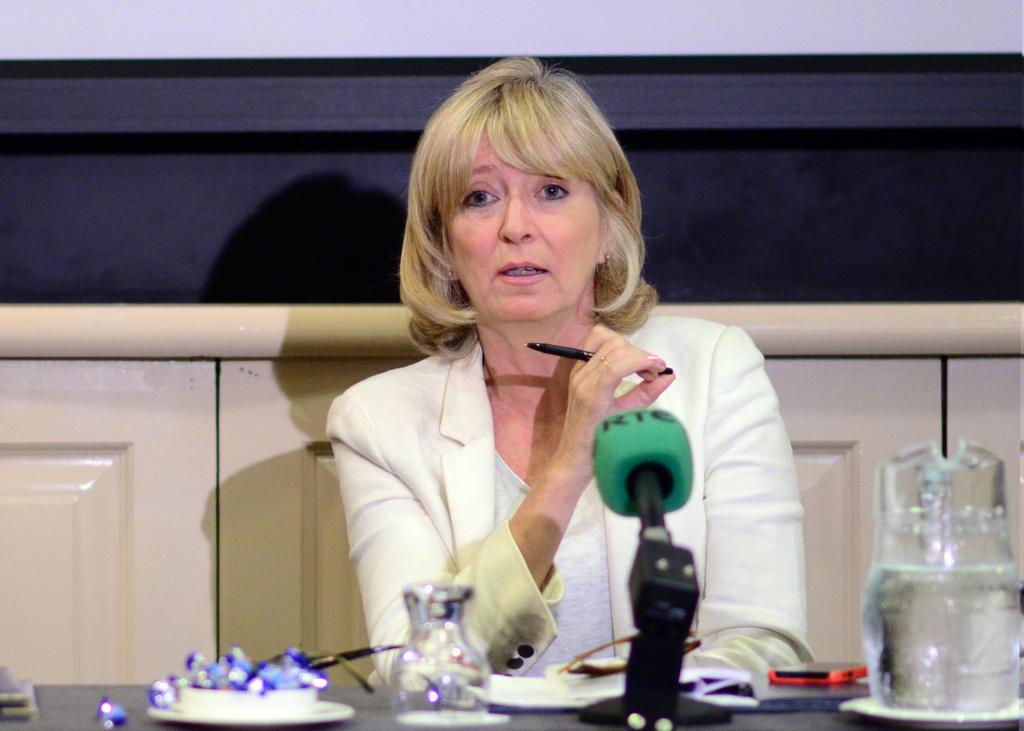What is visible on the green microphone?
Give a very brief answer. Rtc. 